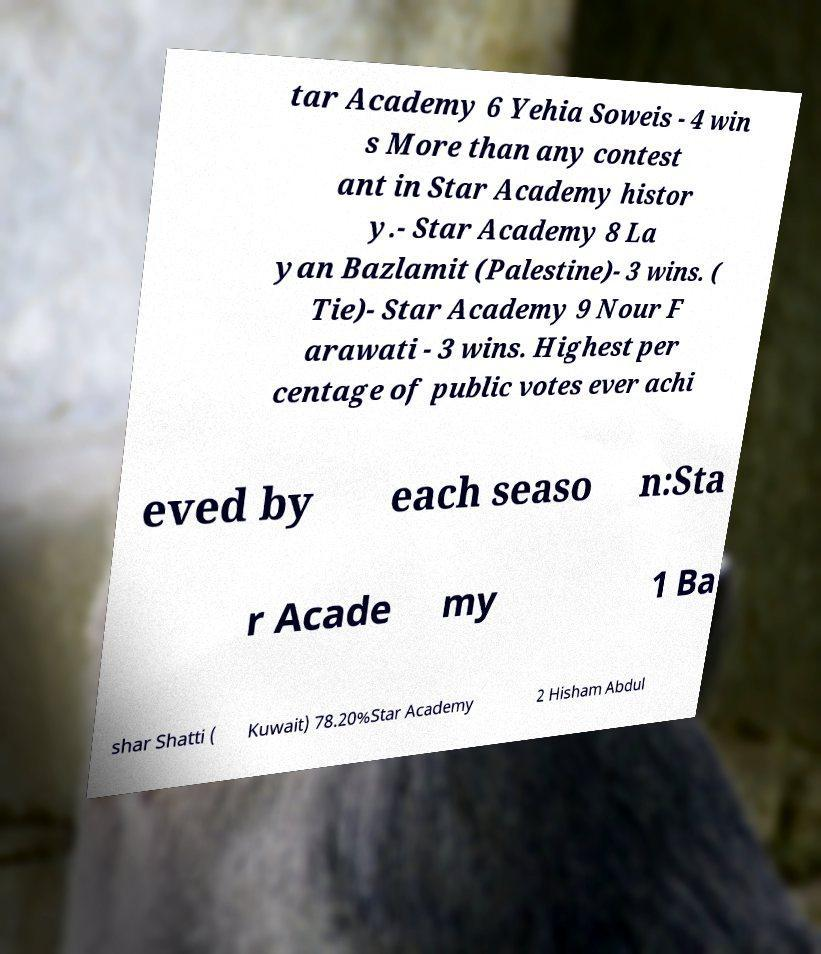Can you accurately transcribe the text from the provided image for me? tar Academy 6 Yehia Soweis - 4 win s More than any contest ant in Star Academy histor y.- Star Academy 8 La yan Bazlamit (Palestine)- 3 wins. ( Tie)- Star Academy 9 Nour F arawati - 3 wins. Highest per centage of public votes ever achi eved by each seaso n:Sta r Acade my 1 Ba shar Shatti ( Kuwait) 78.20%Star Academy 2 Hisham Abdul 